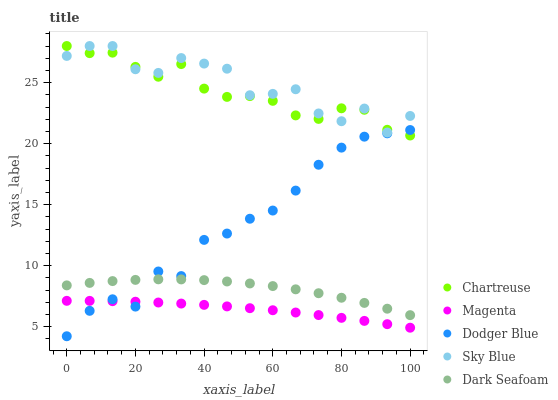Does Magenta have the minimum area under the curve?
Answer yes or no. Yes. Does Sky Blue have the maximum area under the curve?
Answer yes or no. Yes. Does Chartreuse have the minimum area under the curve?
Answer yes or no. No. Does Chartreuse have the maximum area under the curve?
Answer yes or no. No. Is Magenta the smoothest?
Answer yes or no. Yes. Is Sky Blue the roughest?
Answer yes or no. Yes. Is Chartreuse the smoothest?
Answer yes or no. No. Is Chartreuse the roughest?
Answer yes or no. No. Does Dodger Blue have the lowest value?
Answer yes or no. Yes. Does Chartreuse have the lowest value?
Answer yes or no. No. Does Chartreuse have the highest value?
Answer yes or no. Yes. Does Dodger Blue have the highest value?
Answer yes or no. No. Is Magenta less than Dark Seafoam?
Answer yes or no. Yes. Is Sky Blue greater than Magenta?
Answer yes or no. Yes. Does Chartreuse intersect Dodger Blue?
Answer yes or no. Yes. Is Chartreuse less than Dodger Blue?
Answer yes or no. No. Is Chartreuse greater than Dodger Blue?
Answer yes or no. No. Does Magenta intersect Dark Seafoam?
Answer yes or no. No. 